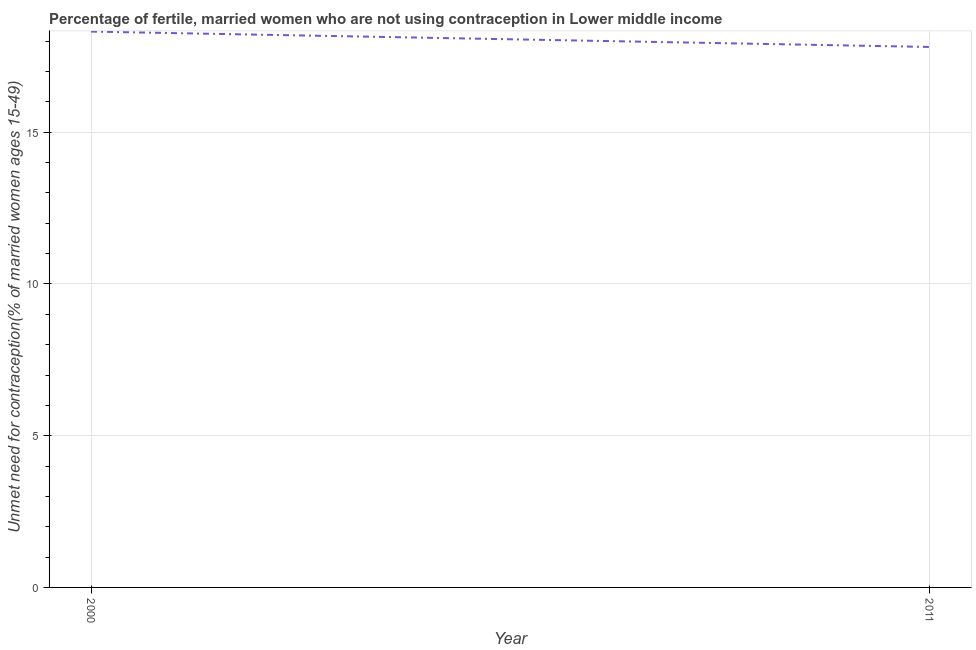What is the number of married women who are not using contraception in 2011?
Provide a succinct answer. 17.81. Across all years, what is the maximum number of married women who are not using contraception?
Your answer should be very brief. 18.32. Across all years, what is the minimum number of married women who are not using contraception?
Ensure brevity in your answer.  17.81. In which year was the number of married women who are not using contraception maximum?
Offer a terse response. 2000. What is the sum of the number of married women who are not using contraception?
Offer a very short reply. 36.13. What is the difference between the number of married women who are not using contraception in 2000 and 2011?
Offer a very short reply. 0.51. What is the average number of married women who are not using contraception per year?
Your answer should be compact. 18.06. What is the median number of married women who are not using contraception?
Offer a terse response. 18.06. In how many years, is the number of married women who are not using contraception greater than 6 %?
Make the answer very short. 2. Do a majority of the years between 2011 and 2000 (inclusive) have number of married women who are not using contraception greater than 7 %?
Your response must be concise. No. What is the ratio of the number of married women who are not using contraception in 2000 to that in 2011?
Keep it short and to the point. 1.03. What is the title of the graph?
Offer a very short reply. Percentage of fertile, married women who are not using contraception in Lower middle income. What is the label or title of the X-axis?
Offer a terse response. Year. What is the label or title of the Y-axis?
Offer a terse response.  Unmet need for contraception(% of married women ages 15-49). What is the  Unmet need for contraception(% of married women ages 15-49) of 2000?
Your response must be concise. 18.32. What is the  Unmet need for contraception(% of married women ages 15-49) in 2011?
Keep it short and to the point. 17.81. What is the difference between the  Unmet need for contraception(% of married women ages 15-49) in 2000 and 2011?
Keep it short and to the point. 0.51. What is the ratio of the  Unmet need for contraception(% of married women ages 15-49) in 2000 to that in 2011?
Your answer should be compact. 1.03. 